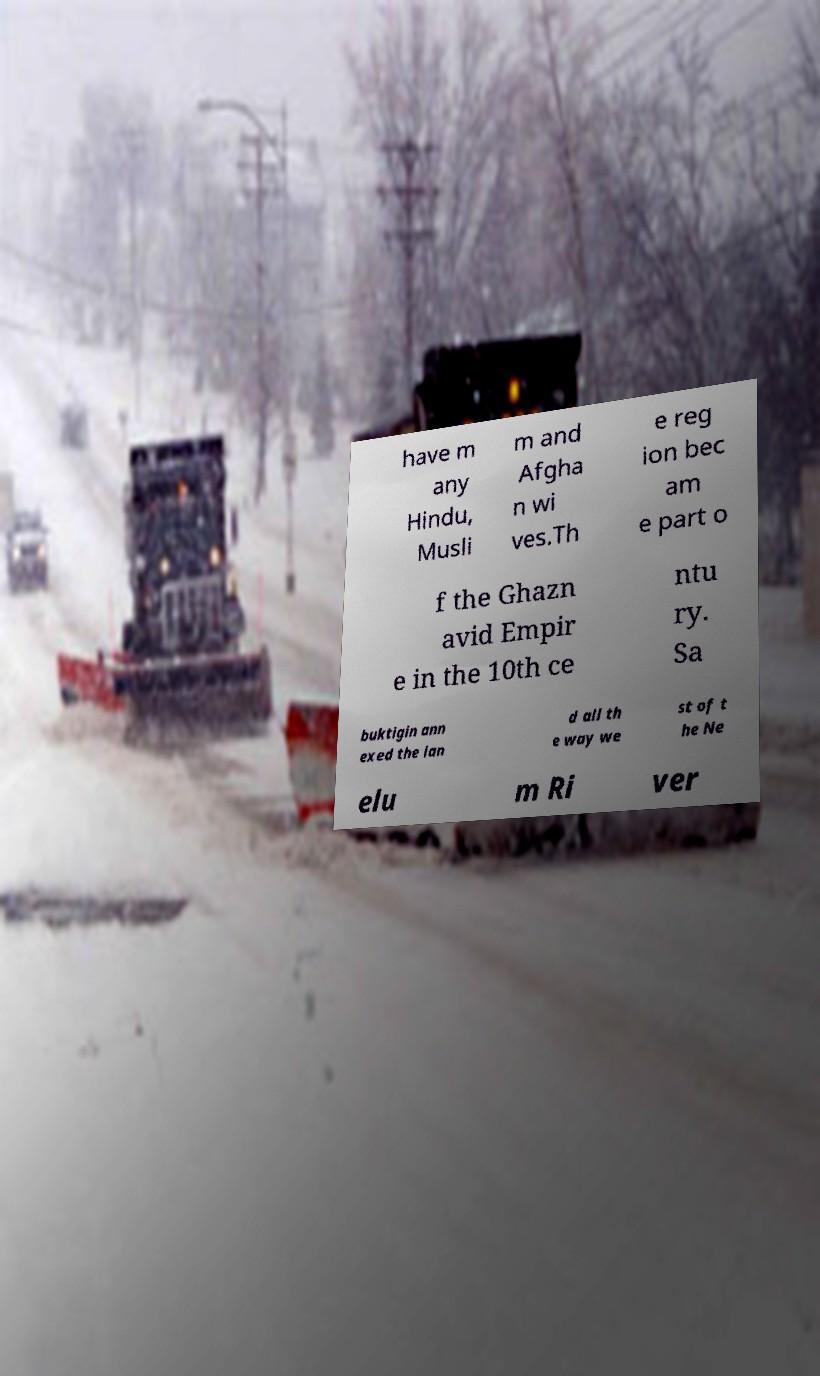Can you read and provide the text displayed in the image?This photo seems to have some interesting text. Can you extract and type it out for me? have m any Hindu, Musli m and Afgha n wi ves.Th e reg ion bec am e part o f the Ghazn avid Empir e in the 10th ce ntu ry. Sa buktigin ann exed the lan d all th e way we st of t he Ne elu m Ri ver 